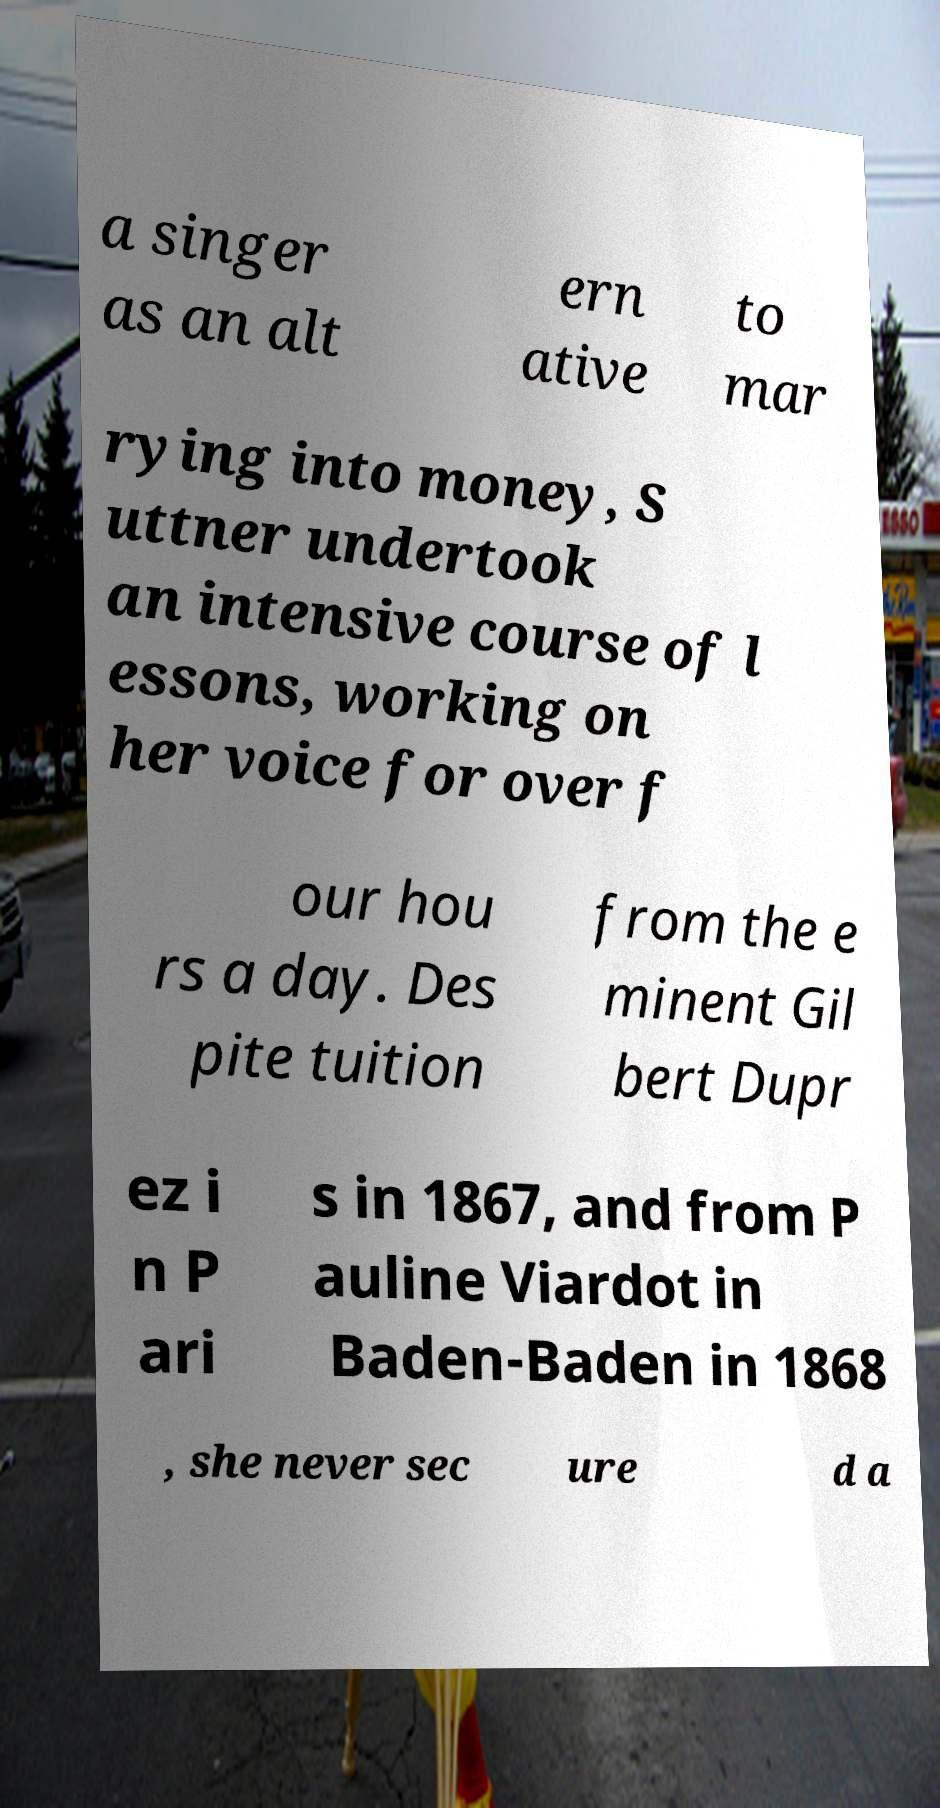There's text embedded in this image that I need extracted. Can you transcribe it verbatim? a singer as an alt ern ative to mar rying into money, S uttner undertook an intensive course of l essons, working on her voice for over f our hou rs a day. Des pite tuition from the e minent Gil bert Dupr ez i n P ari s in 1867, and from P auline Viardot in Baden-Baden in 1868 , she never sec ure d a 